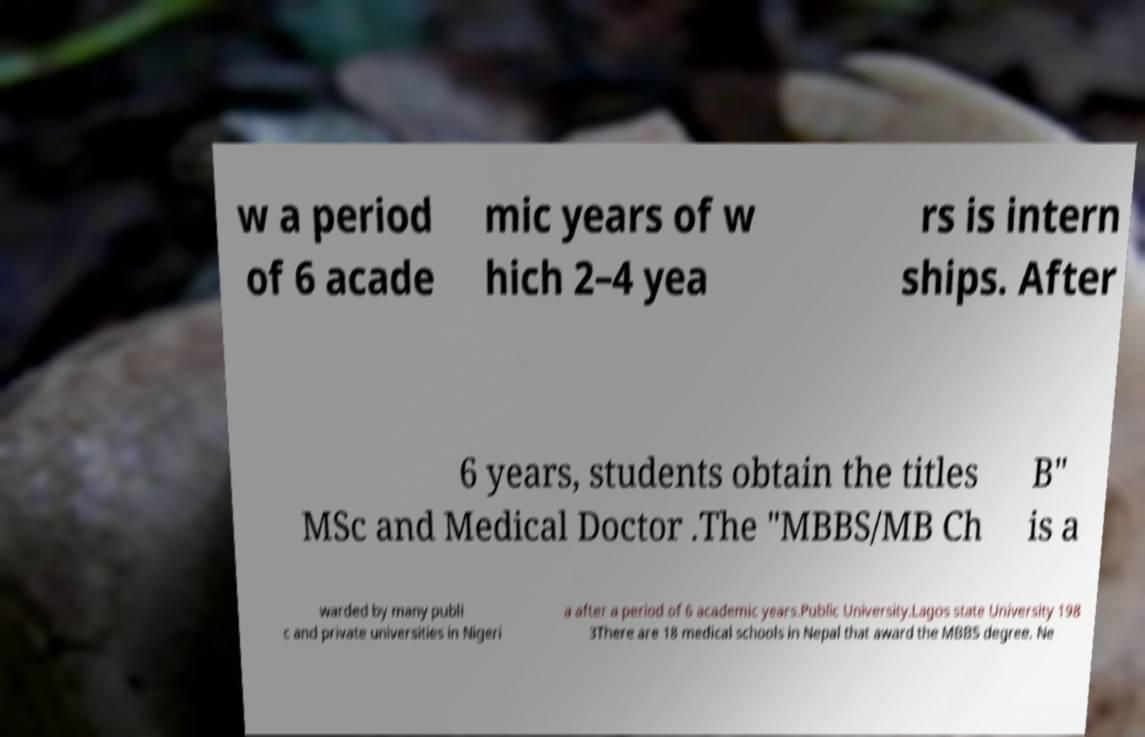Please read and relay the text visible in this image. What does it say? w a period of 6 acade mic years of w hich 2–4 yea rs is intern ships. After 6 years, students obtain the titles MSc and Medical Doctor .The "MBBS/MB Ch B" is a warded by many publi c and private universities in Nigeri a after a period of 6 academic years.Public University.Lagos state University 198 3There are 18 medical schools in Nepal that award the MBBS degree. Ne 